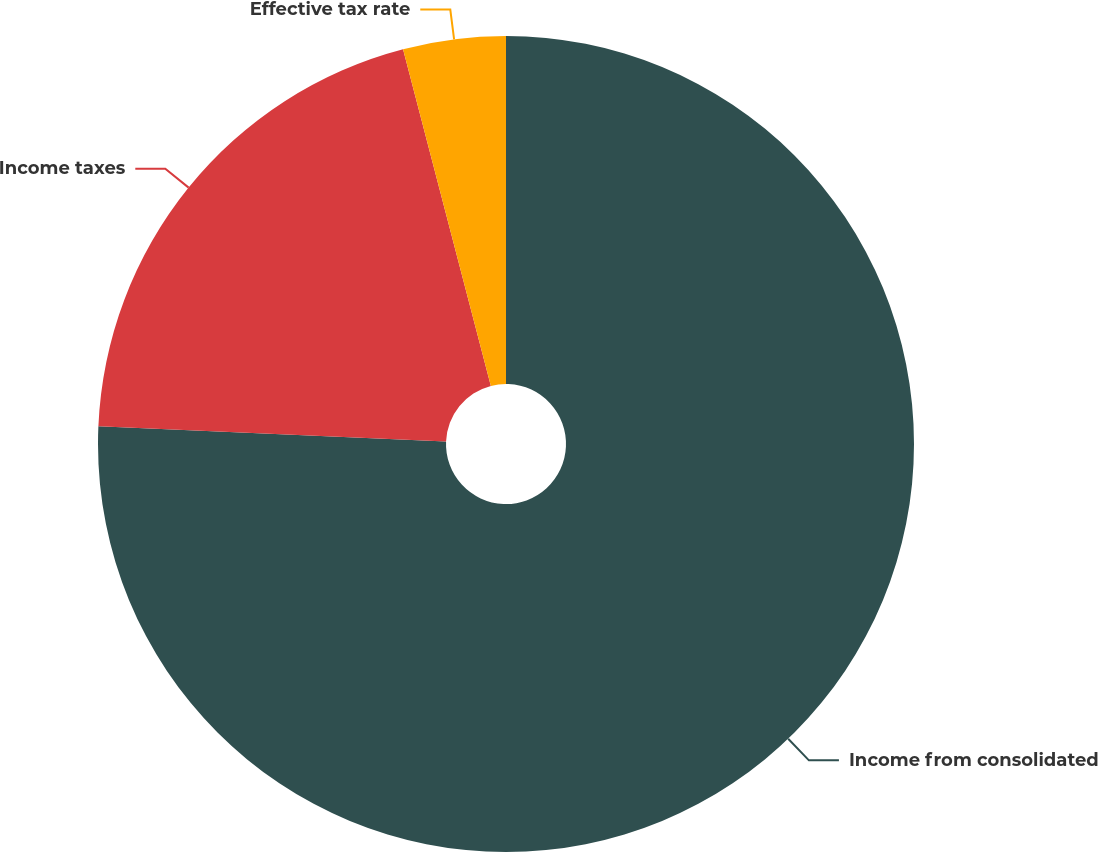Convert chart to OTSL. <chart><loc_0><loc_0><loc_500><loc_500><pie_chart><fcel>Income from consolidated<fcel>Income taxes<fcel>Effective tax rate<nl><fcel>75.69%<fcel>20.25%<fcel>4.06%<nl></chart> 